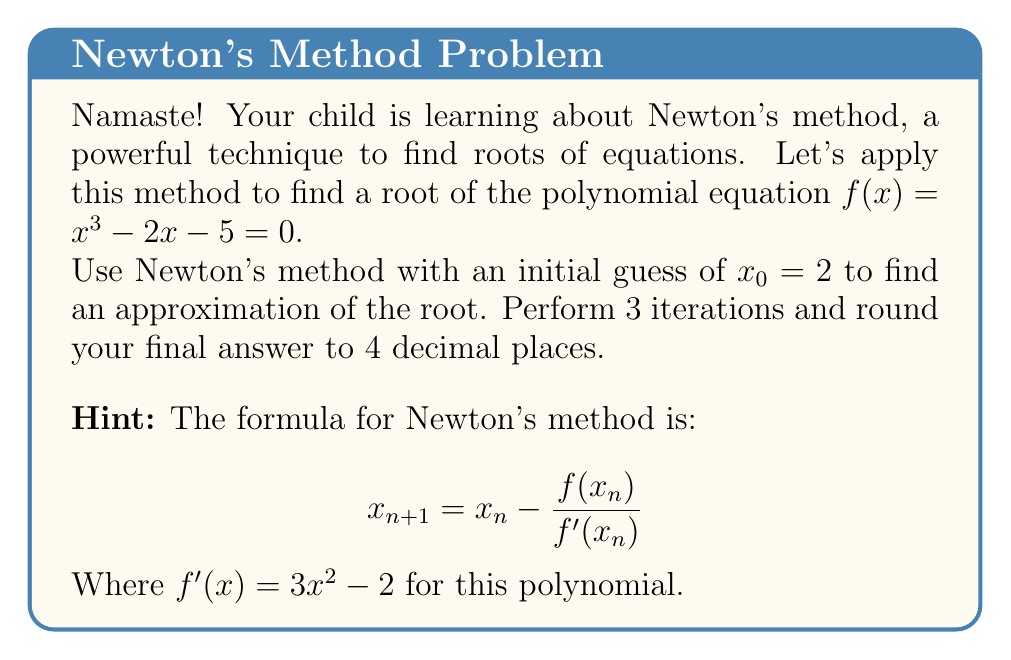Can you answer this question? Let's go through this step-by-step:

1) First, we define our functions:
   $f(x) = x^3 - 2x - 5$
   $f'(x) = 3x^2 - 2$

2) We start with $x_0 = 2$. Let's calculate $x_1$:

   $x_1 = x_0 - \frac{f(x_0)}{f'(x_0)}$

   $f(2) = 2^3 - 2(2) - 5 = 8 - 4 - 5 = -1$
   $f'(2) = 3(2^2) - 2 = 12 - 2 = 10$

   $x_1 = 2 - \frac{-1}{10} = 2 + 0.1 = 2.1$

3) Now let's calculate $x_2$:

   $f(2.1) = 2.1^3 - 2(2.1) - 5 \approx -0.061$
   $f'(2.1) = 3(2.1^2) - 2 \approx 11.23$

   $x_2 = 2.1 - \frac{-0.061}{11.23} \approx 2.1054$

4) Finally, let's calculate $x_3$:

   $f(2.1054) \approx -0.000297$
   $f'(2.1054) \approx 11.3335$

   $x_3 = 2.1054 - \frac{-0.000297}{11.3335} \approx 2.1054$

5) Rounding to 4 decimal places, our final answer is 2.1054.
Answer: 2.1054 